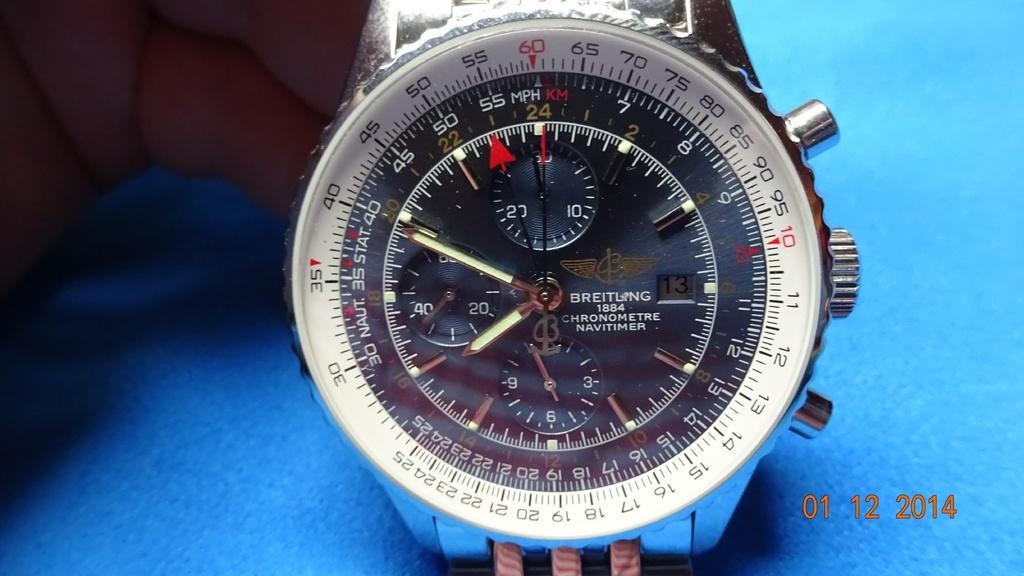Provide a one-sentence caption for the provided image. A wrist watch that has a grey dial and is made by Breitling. 